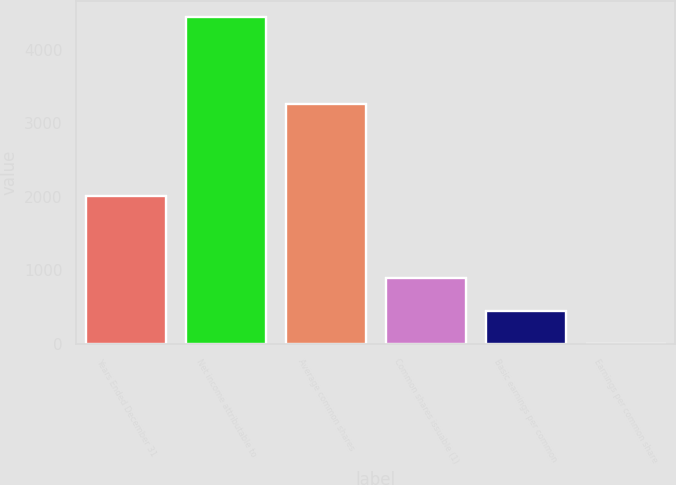Convert chart. <chart><loc_0><loc_0><loc_500><loc_500><bar_chart><fcel>Years Ended December 31<fcel>Net income attributable to<fcel>Average common shares<fcel>Common shares issuable (1)<fcel>Basic earnings per common<fcel>Earnings per common share<nl><fcel>2015<fcel>4442<fcel>3260.04<fcel>889.64<fcel>445.6<fcel>1.56<nl></chart> 